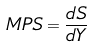<formula> <loc_0><loc_0><loc_500><loc_500>M P S = \frac { d S } { d Y }</formula> 